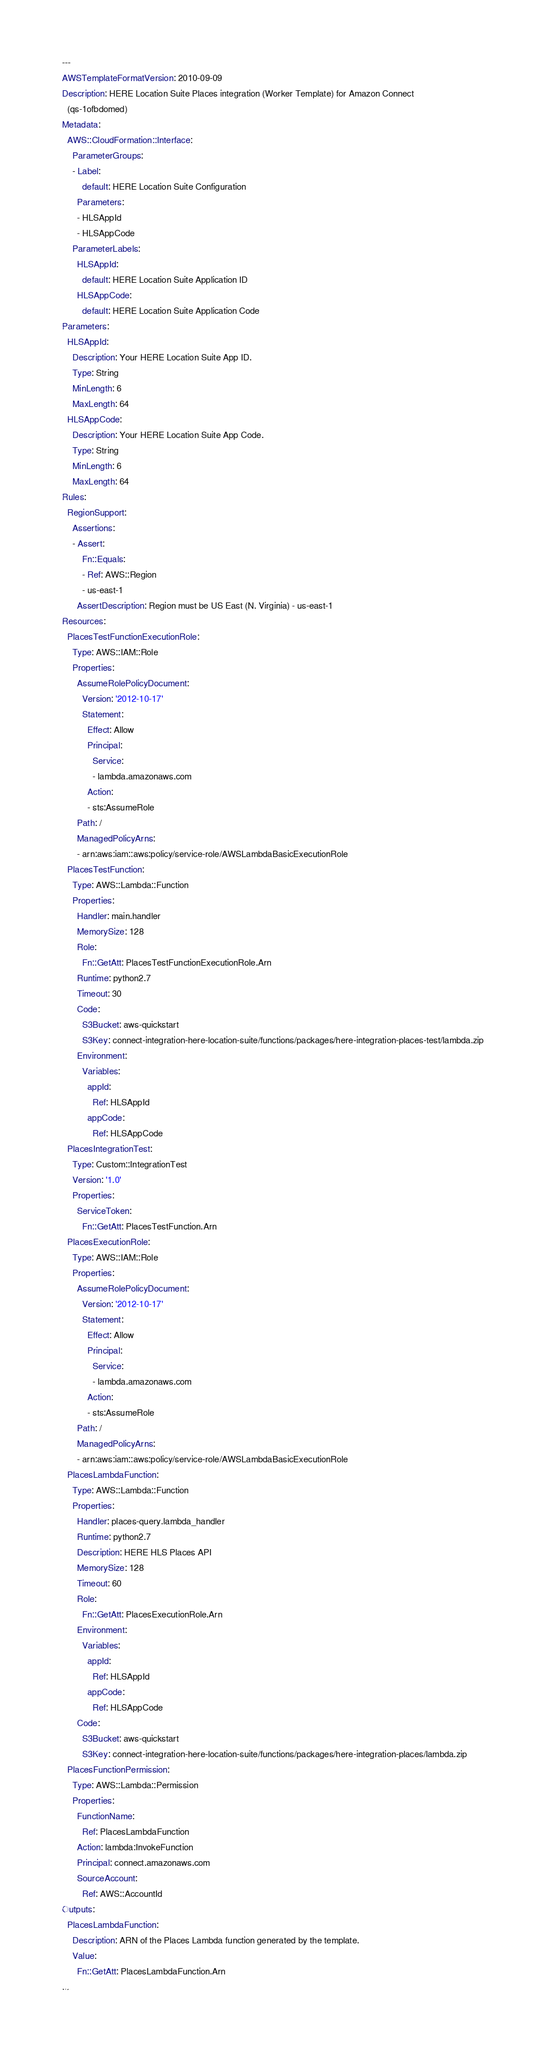Convert code to text. <code><loc_0><loc_0><loc_500><loc_500><_YAML_>---
AWSTemplateFormatVersion: 2010-09-09
Description: HERE Location Suite Places integration (Worker Template) for Amazon Connect
  (qs-1ofbdomed)
Metadata:
  AWS::CloudFormation::Interface:
    ParameterGroups:
    - Label:
        default: HERE Location Suite Configuration
      Parameters:
      - HLSAppId
      - HLSAppCode
    ParameterLabels:
      HLSAppId:
        default: HERE Location Suite Application ID
      HLSAppCode:
        default: HERE Location Suite Application Code
Parameters:
  HLSAppId:
    Description: Your HERE Location Suite App ID.
    Type: String
    MinLength: 6
    MaxLength: 64
  HLSAppCode:
    Description: Your HERE Location Suite App Code.
    Type: String
    MinLength: 6
    MaxLength: 64
Rules:
  RegionSupport:
    Assertions:
    - Assert:
        Fn::Equals:
        - Ref: AWS::Region
        - us-east-1
      AssertDescription: Region must be US East (N. Virginia) - us-east-1
Resources:
  PlacesTestFunctionExecutionRole:
    Type: AWS::IAM::Role
    Properties:
      AssumeRolePolicyDocument:
        Version: '2012-10-17'
        Statement:
          Effect: Allow
          Principal:
            Service:
            - lambda.amazonaws.com
          Action:
          - sts:AssumeRole
      Path: /
      ManagedPolicyArns:
      - arn:aws:iam::aws:policy/service-role/AWSLambdaBasicExecutionRole
  PlacesTestFunction:
    Type: AWS::Lambda::Function
    Properties:
      Handler: main.handler
      MemorySize: 128
      Role:
        Fn::GetAtt: PlacesTestFunctionExecutionRole.Arn
      Runtime: python2.7
      Timeout: 30
      Code:
        S3Bucket: aws-quickstart
        S3Key: connect-integration-here-location-suite/functions/packages/here-integration-places-test/lambda.zip
      Environment:
        Variables:
          appId:
            Ref: HLSAppId
          appCode:
            Ref: HLSAppCode
  PlacesIntegrationTest:
    Type: Custom::IntegrationTest
    Version: '1.0'
    Properties:
      ServiceToken:
        Fn::GetAtt: PlacesTestFunction.Arn
  PlacesExecutionRole:
    Type: AWS::IAM::Role
    Properties:
      AssumeRolePolicyDocument:
        Version: '2012-10-17'
        Statement:
          Effect: Allow
          Principal:
            Service:
            - lambda.amazonaws.com
          Action:
          - sts:AssumeRole
      Path: /
      ManagedPolicyArns:
      - arn:aws:iam::aws:policy/service-role/AWSLambdaBasicExecutionRole
  PlacesLambdaFunction:
    Type: AWS::Lambda::Function
    Properties:
      Handler: places-query.lambda_handler
      Runtime: python2.7
      Description: HERE HLS Places API
      MemorySize: 128
      Timeout: 60
      Role:
        Fn::GetAtt: PlacesExecutionRole.Arn
      Environment:
        Variables:
          appId:
            Ref: HLSAppId
          appCode:
            Ref: HLSAppCode
      Code:
        S3Bucket: aws-quickstart
        S3Key: connect-integration-here-location-suite/functions/packages/here-integration-places/lambda.zip
  PlacesFunctionPermission:
    Type: AWS::Lambda::Permission
    Properties:
      FunctionName:
        Ref: PlacesLambdaFunction
      Action: lambda:InvokeFunction
      Principal: connect.amazonaws.com
      SourceAccount:
        Ref: AWS::AccountId
Outputs:
  PlacesLambdaFunction:
    Description: ARN of the Places Lambda function generated by the template.
    Value:
      Fn::GetAtt: PlacesLambdaFunction.Arn
...
</code> 